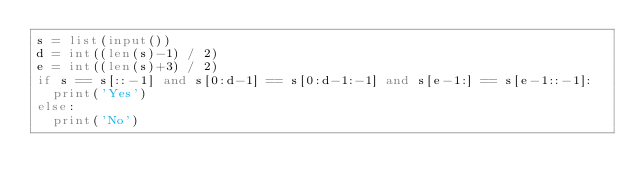Convert code to text. <code><loc_0><loc_0><loc_500><loc_500><_Python_>s = list(input())
d = int((len(s)-1) / 2)
e = int((len(s)+3) / 2)
if s == s[::-1] and s[0:d-1] == s[0:d-1:-1] and s[e-1:] == s[e-1::-1]:
  print('Yes')
else:
  print('No')</code> 